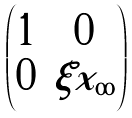Convert formula to latex. <formula><loc_0><loc_0><loc_500><loc_500>\begin{pmatrix} 1 & 0 \\ 0 & \xi x _ { \infty } \end{pmatrix}</formula> 